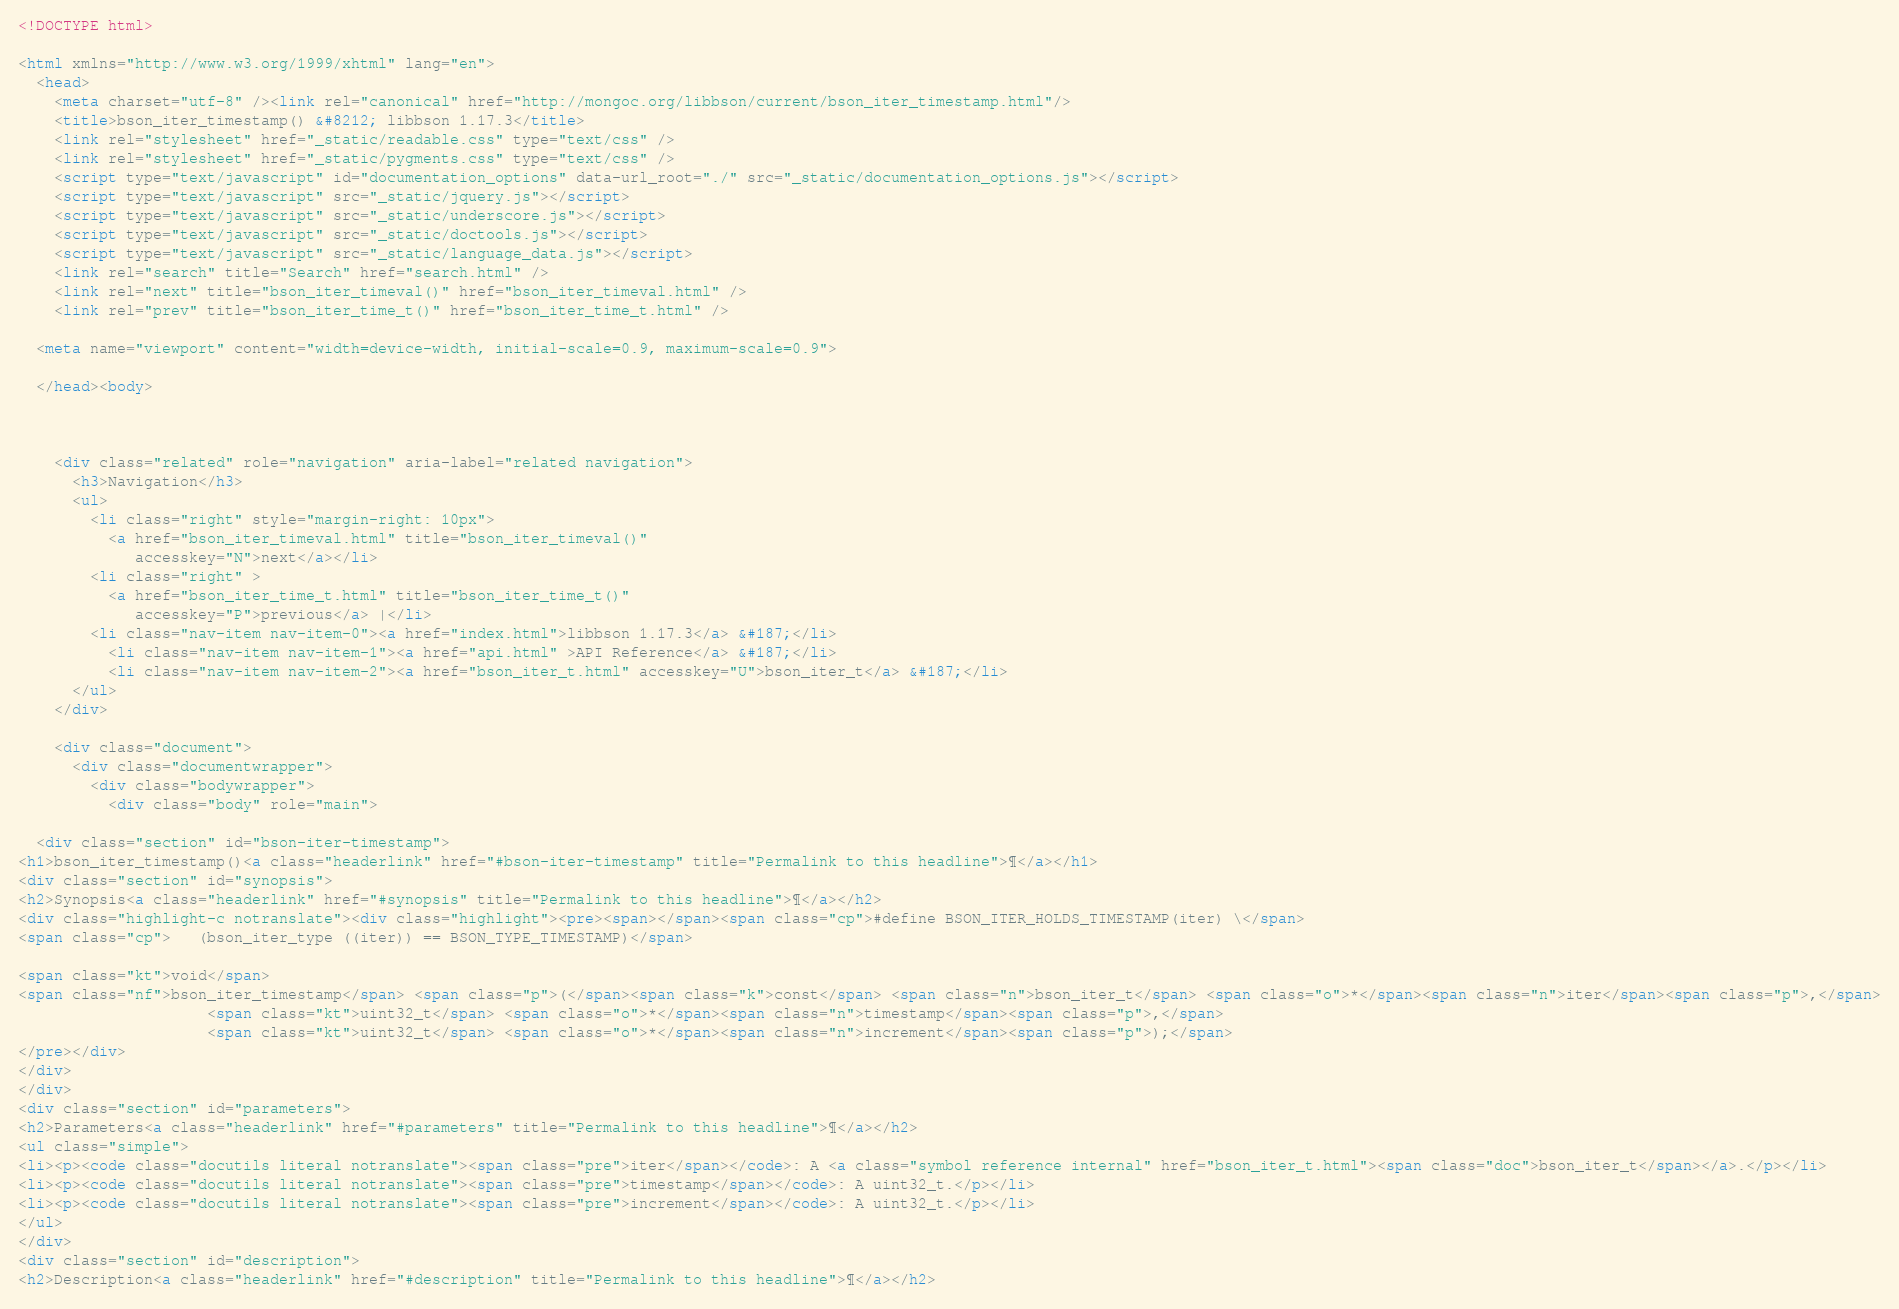<code> <loc_0><loc_0><loc_500><loc_500><_HTML_>
<!DOCTYPE html>

<html xmlns="http://www.w3.org/1999/xhtml" lang="en">
  <head>
    <meta charset="utf-8" /><link rel="canonical" href="http://mongoc.org/libbson/current/bson_iter_timestamp.html"/>
    <title>bson_iter_timestamp() &#8212; libbson 1.17.3</title>
    <link rel="stylesheet" href="_static/readable.css" type="text/css" />
    <link rel="stylesheet" href="_static/pygments.css" type="text/css" />
    <script type="text/javascript" id="documentation_options" data-url_root="./" src="_static/documentation_options.js"></script>
    <script type="text/javascript" src="_static/jquery.js"></script>
    <script type="text/javascript" src="_static/underscore.js"></script>
    <script type="text/javascript" src="_static/doctools.js"></script>
    <script type="text/javascript" src="_static/language_data.js"></script>
    <link rel="search" title="Search" href="search.html" />
    <link rel="next" title="bson_iter_timeval()" href="bson_iter_timeval.html" />
    <link rel="prev" title="bson_iter_time_t()" href="bson_iter_time_t.html" />
   
  <meta name="viewport" content="width=device-width, initial-scale=0.9, maximum-scale=0.9">

  </head><body>
  
  

    <div class="related" role="navigation" aria-label="related navigation">
      <h3>Navigation</h3>
      <ul>
        <li class="right" style="margin-right: 10px">
          <a href="bson_iter_timeval.html" title="bson_iter_timeval()"
             accesskey="N">next</a></li>
        <li class="right" >
          <a href="bson_iter_time_t.html" title="bson_iter_time_t()"
             accesskey="P">previous</a> |</li>
        <li class="nav-item nav-item-0"><a href="index.html">libbson 1.17.3</a> &#187;</li>
          <li class="nav-item nav-item-1"><a href="api.html" >API Reference</a> &#187;</li>
          <li class="nav-item nav-item-2"><a href="bson_iter_t.html" accesskey="U">bson_iter_t</a> &#187;</li> 
      </ul>
    </div>  

    <div class="document">
      <div class="documentwrapper">
        <div class="bodywrapper">
          <div class="body" role="main">
            
  <div class="section" id="bson-iter-timestamp">
<h1>bson_iter_timestamp()<a class="headerlink" href="#bson-iter-timestamp" title="Permalink to this headline">¶</a></h1>
<div class="section" id="synopsis">
<h2>Synopsis<a class="headerlink" href="#synopsis" title="Permalink to this headline">¶</a></h2>
<div class="highlight-c notranslate"><div class="highlight"><pre><span></span><span class="cp">#define BSON_ITER_HOLDS_TIMESTAMP(iter) \</span>
<span class="cp">   (bson_iter_type ((iter)) == BSON_TYPE_TIMESTAMP)</span>

<span class="kt">void</span>
<span class="nf">bson_iter_timestamp</span> <span class="p">(</span><span class="k">const</span> <span class="n">bson_iter_t</span> <span class="o">*</span><span class="n">iter</span><span class="p">,</span>
                     <span class="kt">uint32_t</span> <span class="o">*</span><span class="n">timestamp</span><span class="p">,</span>
                     <span class="kt">uint32_t</span> <span class="o">*</span><span class="n">increment</span><span class="p">);</span>
</pre></div>
</div>
</div>
<div class="section" id="parameters">
<h2>Parameters<a class="headerlink" href="#parameters" title="Permalink to this headline">¶</a></h2>
<ul class="simple">
<li><p><code class="docutils literal notranslate"><span class="pre">iter</span></code>: A <a class="symbol reference internal" href="bson_iter_t.html"><span class="doc">bson_iter_t</span></a>.</p></li>
<li><p><code class="docutils literal notranslate"><span class="pre">timestamp</span></code>: A uint32_t.</p></li>
<li><p><code class="docutils literal notranslate"><span class="pre">increment</span></code>: A uint32_t.</p></li>
</ul>
</div>
<div class="section" id="description">
<h2>Description<a class="headerlink" href="#description" title="Permalink to this headline">¶</a></h2></code> 